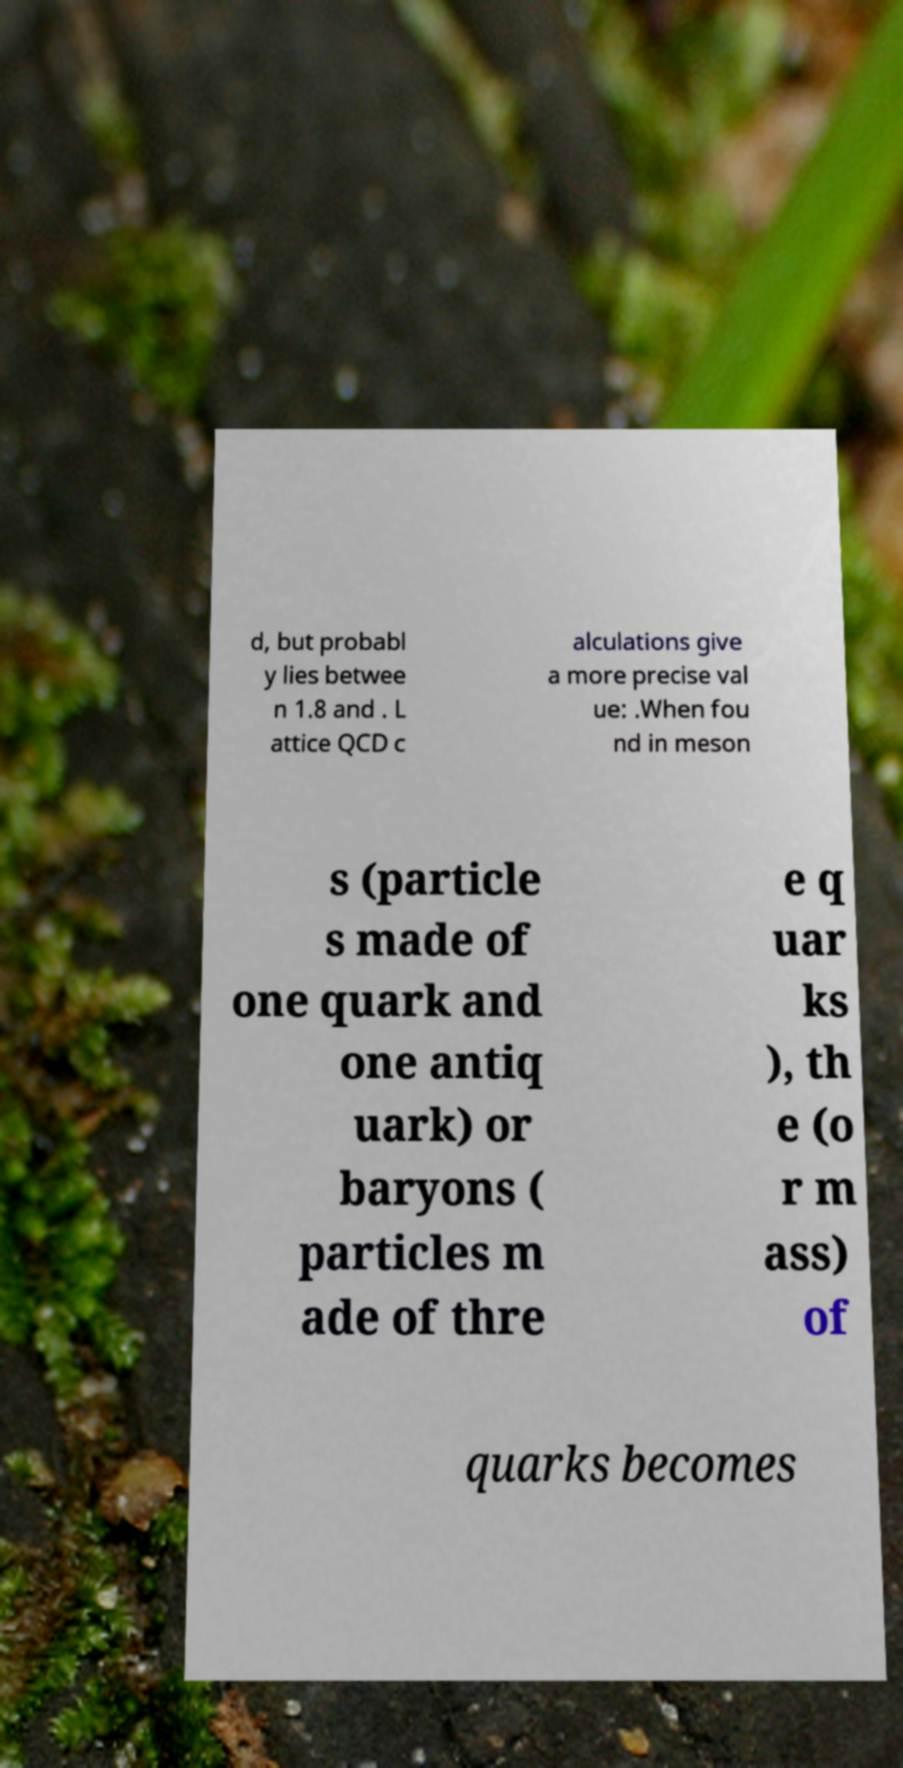I need the written content from this picture converted into text. Can you do that? d, but probabl y lies betwee n 1.8 and . L attice QCD c alculations give a more precise val ue: .When fou nd in meson s (particle s made of one quark and one antiq uark) or baryons ( particles m ade of thre e q uar ks ), th e (o r m ass) of quarks becomes 